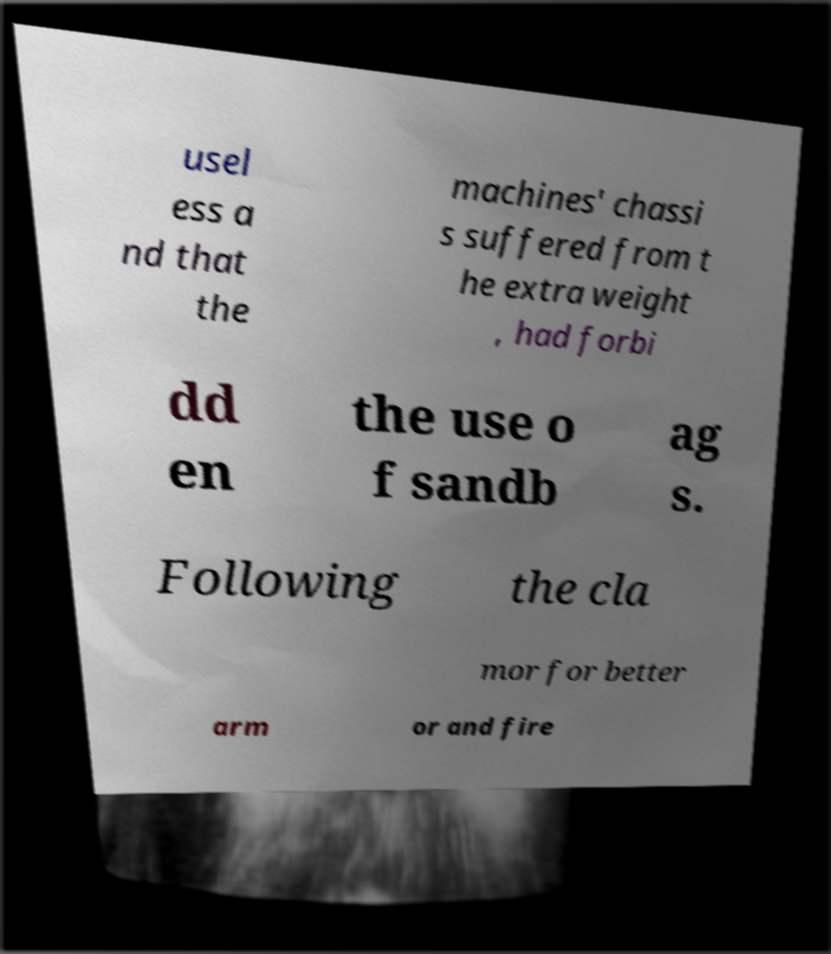Please identify and transcribe the text found in this image. usel ess a nd that the machines' chassi s suffered from t he extra weight , had forbi dd en the use o f sandb ag s. Following the cla mor for better arm or and fire 